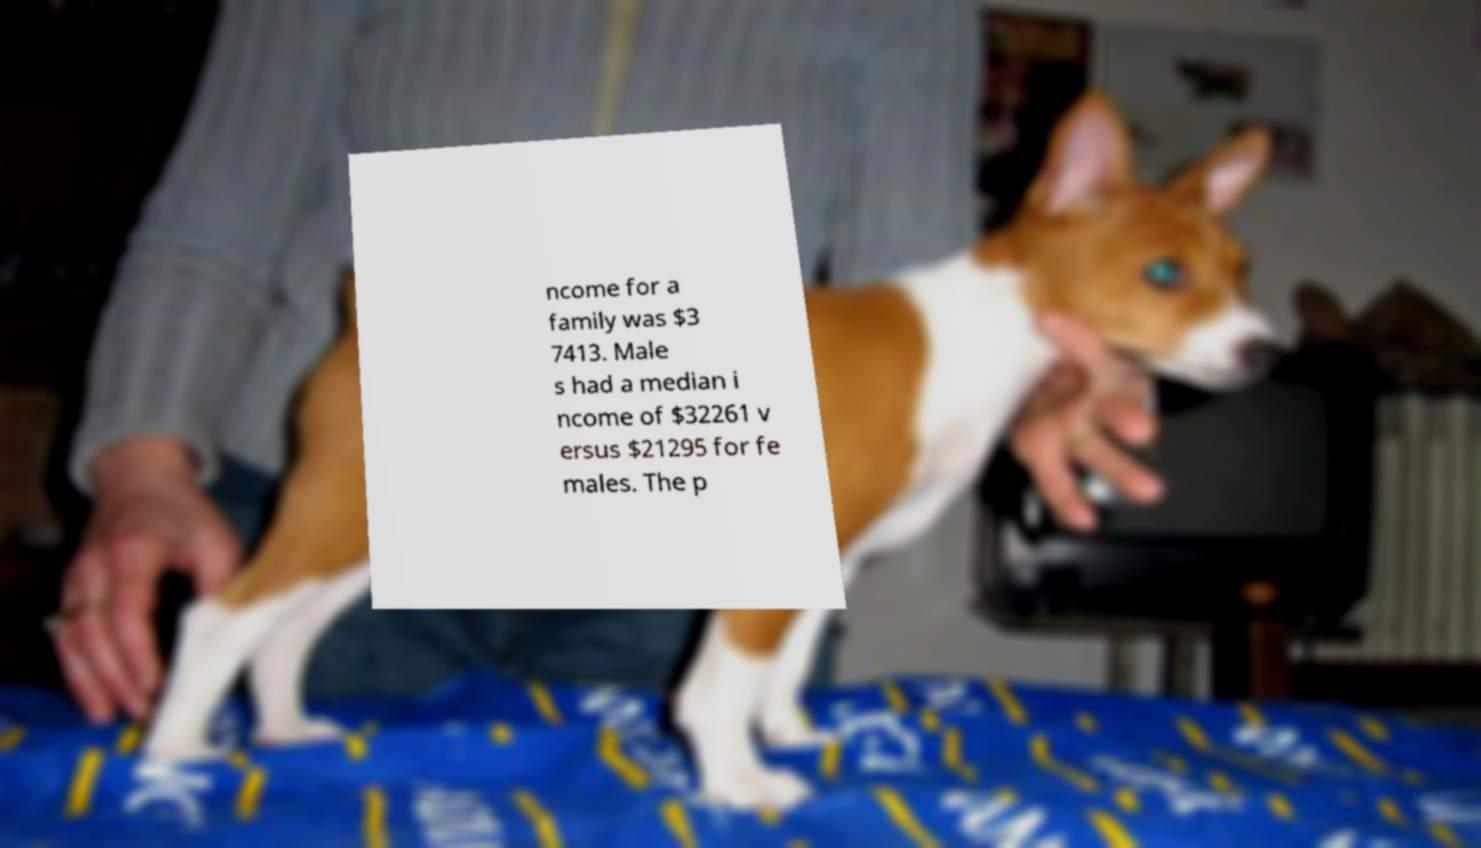Could you extract and type out the text from this image? ncome for a family was $3 7413. Male s had a median i ncome of $32261 v ersus $21295 for fe males. The p 